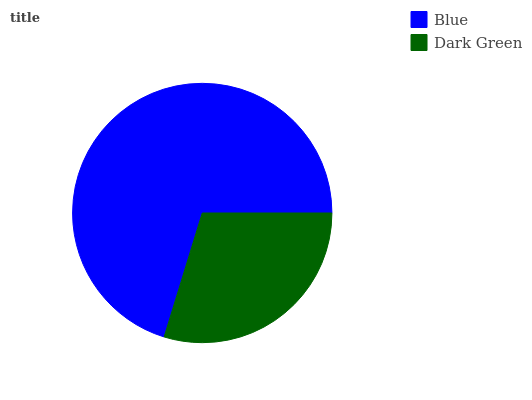Is Dark Green the minimum?
Answer yes or no. Yes. Is Blue the maximum?
Answer yes or no. Yes. Is Dark Green the maximum?
Answer yes or no. No. Is Blue greater than Dark Green?
Answer yes or no. Yes. Is Dark Green less than Blue?
Answer yes or no. Yes. Is Dark Green greater than Blue?
Answer yes or no. No. Is Blue less than Dark Green?
Answer yes or no. No. Is Blue the high median?
Answer yes or no. Yes. Is Dark Green the low median?
Answer yes or no. Yes. Is Dark Green the high median?
Answer yes or no. No. Is Blue the low median?
Answer yes or no. No. 